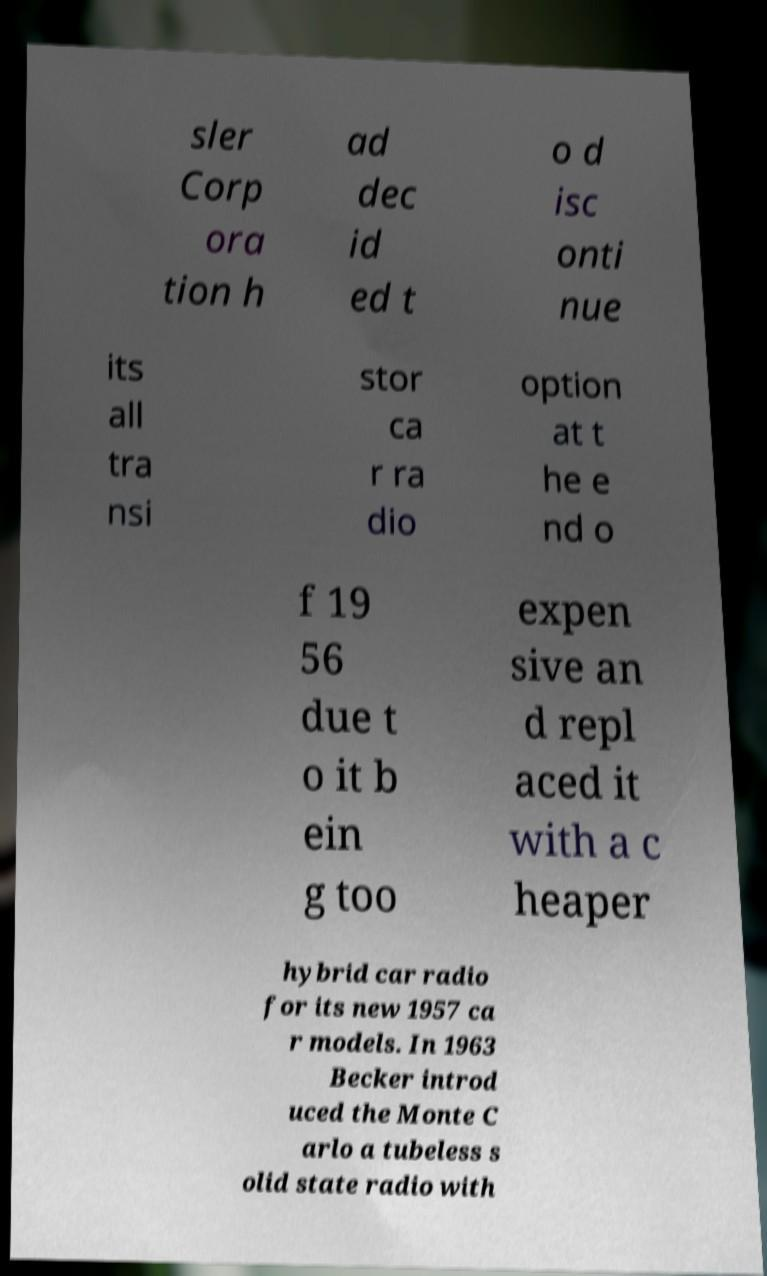What messages or text are displayed in this image? I need them in a readable, typed format. sler Corp ora tion h ad dec id ed t o d isc onti nue its all tra nsi stor ca r ra dio option at t he e nd o f 19 56 due t o it b ein g too expen sive an d repl aced it with a c heaper hybrid car radio for its new 1957 ca r models. In 1963 Becker introd uced the Monte C arlo a tubeless s olid state radio with 